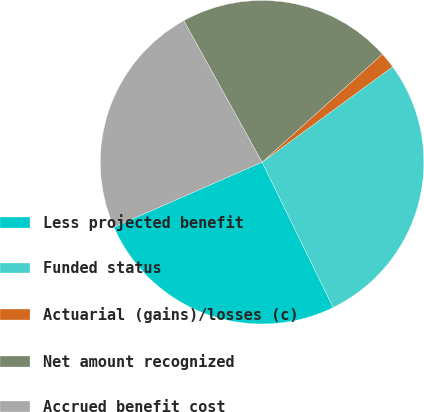Convert chart to OTSL. <chart><loc_0><loc_0><loc_500><loc_500><pie_chart><fcel>Less projected benefit<fcel>Funded status<fcel>Actuarial (gains)/losses (c)<fcel>Net amount recognized<fcel>Accrued benefit cost<nl><fcel>25.67%<fcel>27.81%<fcel>1.6%<fcel>21.39%<fcel>23.53%<nl></chart> 